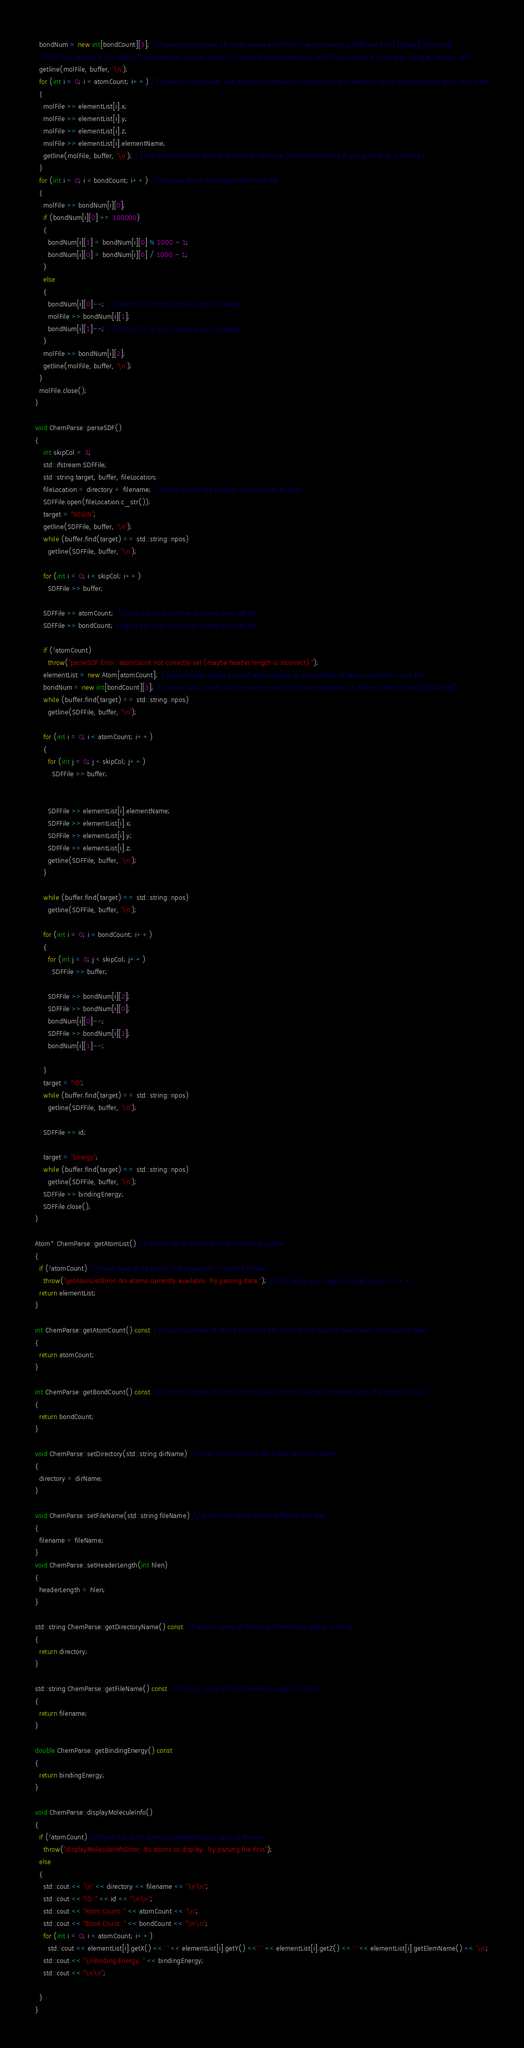<code> <loc_0><loc_0><loc_500><loc_500><_C++_>  bondNum = new int[bondCount][3]; //dynamically create 2D array where each from row represents a different bond ([rows][columns])
  //the first column is the index of one element, second column is index of second element, and third column is bond type (single, double, etc)
  getline(molFile, buffer, '\n');
  for (int i = 0; i < atomCount; i++) //initialize coordinates and element abbreviation of each atom in element list to corresponding atom in mol file
  {
    molFile >> elementList[i].x;
    molFile >> elementList[i].y;
    molFile >> elementList[i].z;
    molFile >> elementList[i].elementName;
    getline(molFile, buffer, '\n'); //skip the rest of the data and move to next line (this makes sense if you go look at a mol file)
  }
  for (int i = 0; i < bondCount; i++) //initialize bond information from mol file
  {
    molFile >> bondNum[i][0];
    if (bondNum[i][0] >= 100000)
    {
      bondNum[i][1] = bondNum[i][0] % 1000 - 1;
      bondNum[i][0] = bondNum[i][0] / 1000 - 1;
    }
    else
    {
      bondNum[i][0]--; //subtract 1 so bond index is zero-indexed
      molFile >> bondNum[i][1];
      bondNum[i][1]--; //subtract 1 so bond index is zero-indexed
    }
    molFile >> bondNum[i][2];
    getline(molFile, buffer, '\n');
  }
  molFile.close();
}

void ChemParse::parseSDF()
{
    int skipCol = 3;
    std::ifstream SDFFile;
    std::string target, buffer, fileLocation;
    fileLocation = directory + filename; //name of mol file location on computer to open
    SDFFile.open(fileLocation.c_str());
    target = "BEGIN";
    getline(SDFFile, buffer, '\n');
    while (buffer.find(target) == std::string::npos)
      getline(SDFFile, buffer, '\n');

    for (int i = 0; i < skipCol; i++)
      SDFFile >> buffer;

    SDFFile >> atomCount; //gets the total number of atoms from sdf file
    SDFFile >> bondCount; //gets the total number of bonds from sdf file

    if (!atomCount)
      throw("parseSDF Error: atomCount not correctly set (maybe header length is incorrect).");
    elementList = new Atom[atomCount]; //dynamically create a list of atoms based on the number of atoms in listed in mol file
    bondNum = new int[bondCount][3]; //dynamically create 2D array where each from row represents a different bond ([rows][columns])
    while (buffer.find(target) == std::string::npos)
      getline(SDFFile, buffer, '\n');

    for (int i = 0; i < atomCount; i++)
    {
      for (int j = 0; j < skipCol; j++)
        SDFFile >> buffer;


      SDFFile >> elementList[i].elementName;
      SDFFile >> elementList[i].x;
      SDFFile >> elementList[i].y;
      SDFFile >> elementList[i].z;
      getline(SDFFile, buffer, '\n');
    }

    while (buffer.find(target) == std::string::npos)
      getline(SDFFile, buffer, '\n');

    for (int i = 0; i < bondCount; i++)
    {
      for (int j = 0; j < skipCol; j++)
        SDFFile >> buffer;

      SDFFile >> bondNum[i][2];
      SDFFile >> bondNum[i][0];
      bondNum[i][0]--;
      SDFFile >> bondNum[i][1];
      bondNum[i][1]--;

    }
    target = "ID";
    while (buffer.find(target) == std::string::npos)
      getline(SDFFile, buffer, '\n');

    SDFFile >> id;

    target = "Energy";
    while (buffer.find(target) == std::string::npos)
      getline(SDFFile, buffer, '\n');
    SDFFile >> bindingEnergy;
    SDFFile.close();
}

Atom* ChemParse::getAtomList() //returns list of atoms for use in other program
{
  if (!atomCount) //there have to be atoms in elementList or error is thrown
    throw("getAtomListError: No atoms currently available. Try parsing data."); //not really sure how to handle errors in C++
  return elementList;
}

int ChemParse::getAtomCount() const //returns number of atoms from mol file (if mole file has not been read, the count is zero)
{
  return atomCount;
}

int ChemParse::getBondCount() const //returns number of bond from mol file (if mole file has not been read, the count is zero)
{
  return bondCount;
}

void ChemParse::setDirectory(std::string dirName) //gives user option to set a new directory name
{
  directory = dirName;
}

void ChemParse::setFileName(std::string fileName) //gives user option to set different mol files
{
  filename = fileName;
}
void ChemParse::setHeaderLength(int hlen)
{
  headerLength = hlen;
}

std::string ChemParse::getDirectoryName() const //returns name of directory ChemParse object is set to
{
  return directory;
}

std::string ChemParse::getFileName() const //returns name of file ChemParse object is set to
{
  return filename;
}

double ChemParse::getBindingEnergy() const
{
  return bindingEnergy;
}

void ChemParse::displayMoleculeInfo()
{
  if (!atomCount) //there has to be atoms in elementList or error is thrown
    throw("displayMoleculeInfoError: No atoms to display. Try parsing file first");
  else
  {
    std::cout << '\n' << directory << filename << "\n\n";
    std::cout << "ID: " << id << "\n\n";
    std::cout << "Atom Count: " << atomCount << '\n';
    std::cout << "Bond Count: " << bondCount << "\n\n";
    for (int i = 0; i < atomCount; i++)
      std::cout << elementList[i].getX() << ' ' << elementList[i].getY() << ' ' << elementList[i].getZ() << ' ' << elementList[i].getElemName() << '\n';
    std::cout << "\nBinding Energy: " << bindingEnergy;
    std::cout << "\n\n";

  }
}
</code> 